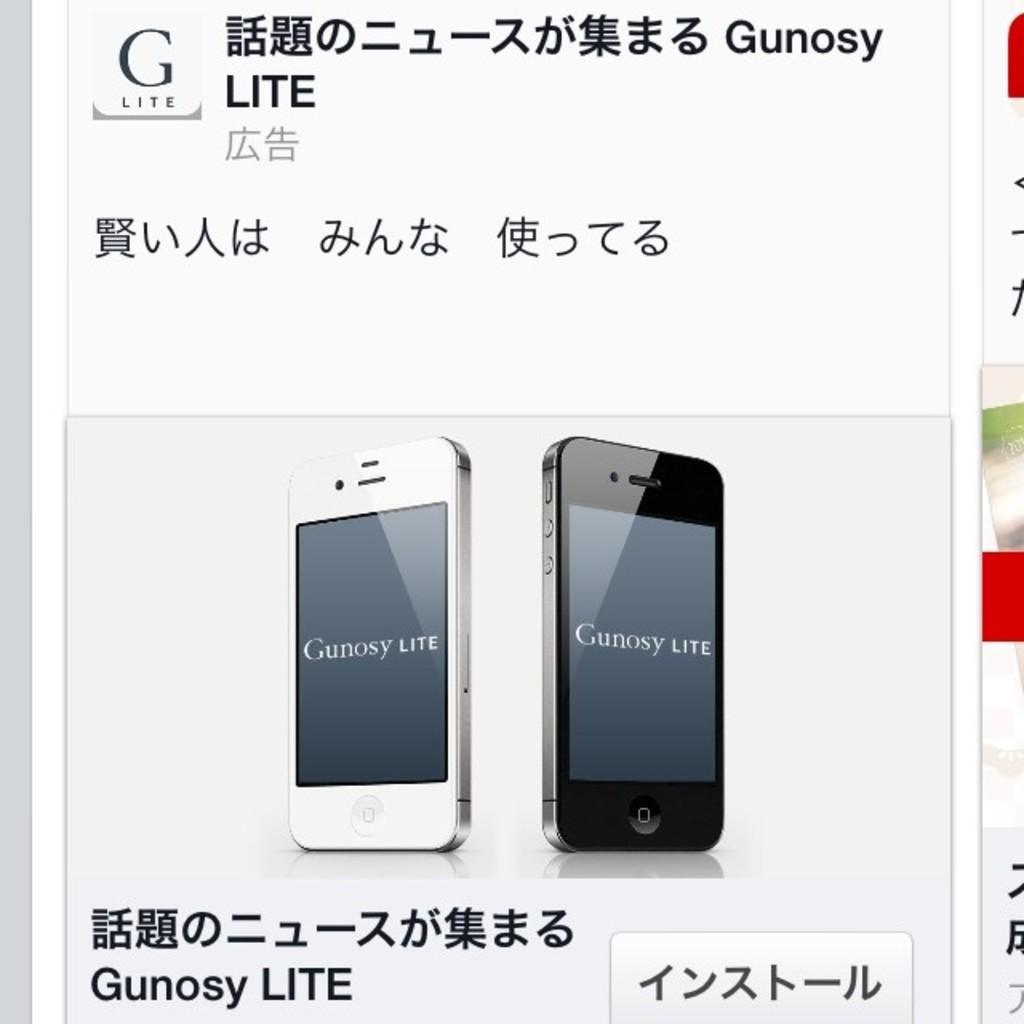<image>
Create a compact narrative representing the image presented. Two smart phones surrounded by foreign text that say Gunosy LITE on the screens. 